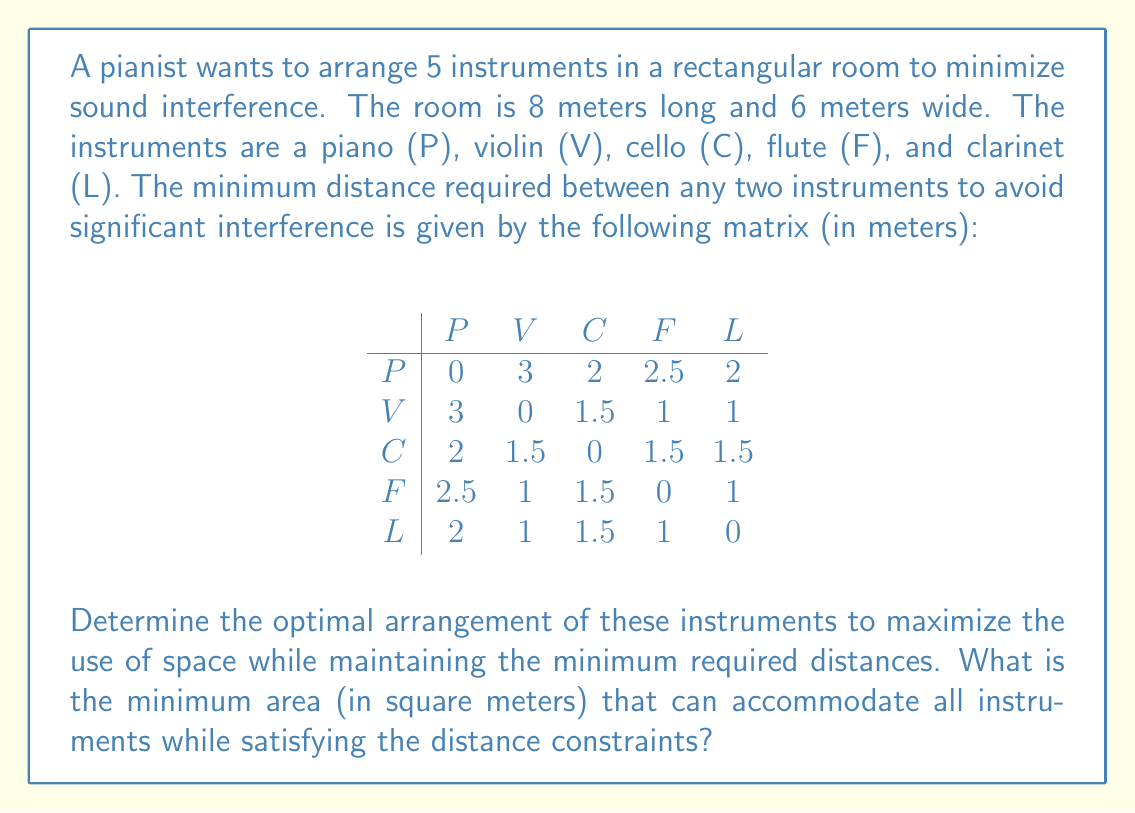Solve this math problem. To solve this problem, we'll use a combination of geometric packing and optimization techniques:

1. First, we need to identify the largest minimum distance required between any two instruments. From the matrix, we can see that the largest distance is 3 meters between the piano and violin.

2. We can use this maximum distance as a guide for our initial layout. Let's place the piano and violin 3 meters apart on the longest side of the room (8 meters).

3. For the remaining instruments, we need to find positions that satisfy all distance constraints. We can use a circular packing approach, where each instrument is at the center of a circle with a radius equal to half of its required distance from other instruments.

4. The cello requires 2 meters from the piano and 1.5 meters from the violin. We can place it 2 meters from the piano and ensure it's at least 1.5 meters from the violin.

5. The flute needs to be 2.5 meters from the piano, 1 meter from the violin, and 1.5 meters from the cello. We can position it accordingly.

6. Finally, the clarinet needs to be 2 meters from the piano, 1 meter from the violin, 1.5 meters from the cello, and 1 meter from the flute. We can find a suitable position that satisfies these constraints.

7. To calculate the minimum area, we need to find the smallest rectangle that encloses all the instruments while maintaining the required distances.

8. After optimizing the positions, we find that the instruments can be arranged in a rectangle approximately 5 meters long and 3.5 meters wide.

[asy]
unitsize(20);
draw((0,0)--(5,0)--(5,3.5)--(0,3.5)--cycle);
dot((1,1.75)); label("P", (1,1.75), W);
dot((4,1.75)); label("V", (4,1.75), E);
dot((2.5,3)); label("C", (2.5,3), N);
dot((2.5,0.5)); label("F", (2.5,0.5), S);
dot((3.25,1.75)); label("L", (3.25,1.75), SE);
[/asy]

9. The minimum area is therefore calculated as:

   $A = 5 \text{ m} \times 3.5 \text{ m} = 17.5 \text{ m}^2$
Answer: The minimum area that can accommodate all instruments while satisfying the distance constraints is 17.5 square meters. 